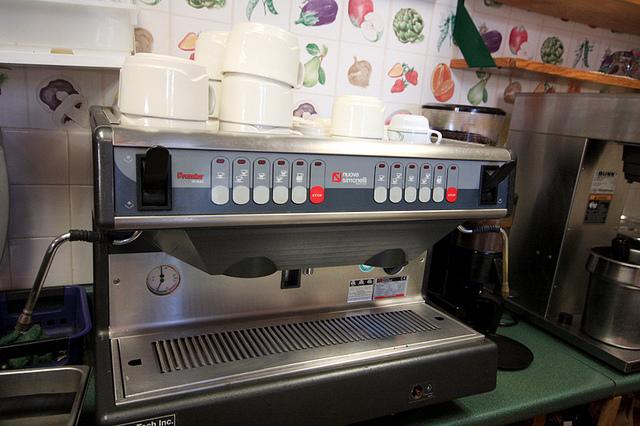Where is this trophy sitting?
Answer briefly. No trophy. Is this a coffee maker?
Short answer required. Yes. What appliance is shown?
Give a very brief answer. Coffee maker. Who uses this machine?
Be succinct. Barista. What is on the backsplash?
Write a very short answer. Vegetables. Is this an oven?
Short answer required. No. 